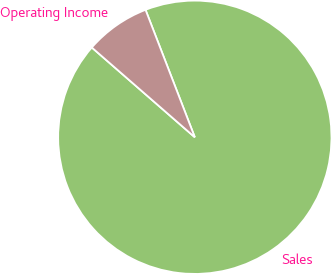<chart> <loc_0><loc_0><loc_500><loc_500><pie_chart><fcel>Sales<fcel>Operating Income<nl><fcel>92.28%<fcel>7.72%<nl></chart> 